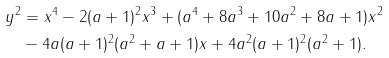Convert formula to latex. <formula><loc_0><loc_0><loc_500><loc_500>y ^ { 2 } & = x ^ { 4 } - 2 ( a + 1 ) ^ { 2 } x ^ { 3 } + ( a ^ { 4 } + 8 a ^ { 3 } + 1 0 a ^ { 2 } + 8 a + 1 ) x ^ { 2 } \\ & - 4 a ( a + 1 ) ^ { 2 } ( a ^ { 2 } + a + 1 ) x + 4 a ^ { 2 } ( a + 1 ) ^ { 2 } ( a ^ { 2 } + 1 ) .</formula> 